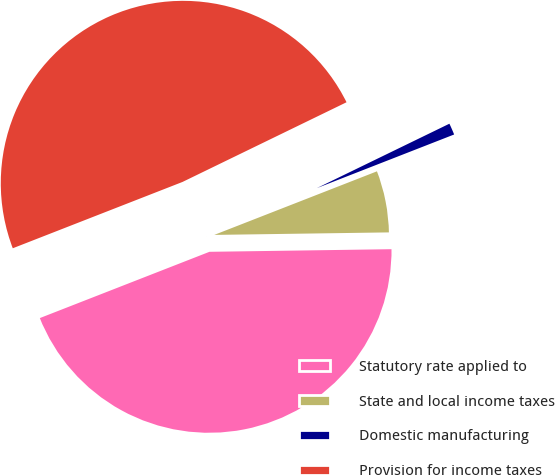Convert chart. <chart><loc_0><loc_0><loc_500><loc_500><pie_chart><fcel>Statutory rate applied to<fcel>State and local income taxes<fcel>Domestic manufacturing<fcel>Provision for income taxes<nl><fcel>44.3%<fcel>5.7%<fcel>1.27%<fcel>48.73%<nl></chart> 